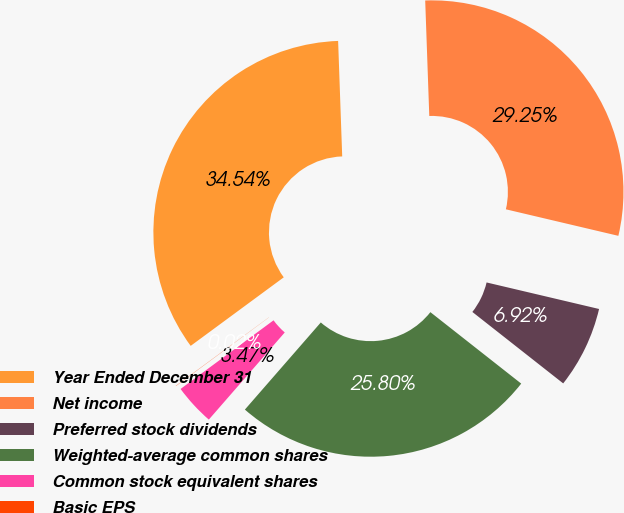<chart> <loc_0><loc_0><loc_500><loc_500><pie_chart><fcel>Year Ended December 31<fcel>Net income<fcel>Preferred stock dividends<fcel>Weighted-average common shares<fcel>Common stock equivalent shares<fcel>Basic EPS<nl><fcel>34.54%<fcel>29.25%<fcel>6.92%<fcel>25.8%<fcel>3.47%<fcel>0.02%<nl></chart> 